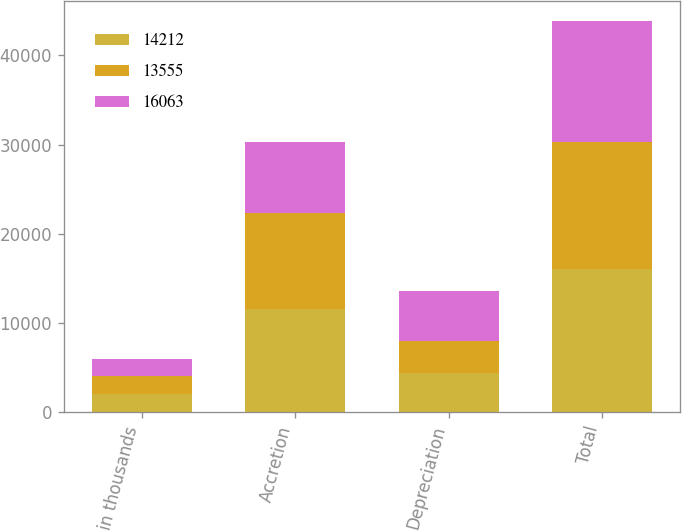<chart> <loc_0><loc_0><loc_500><loc_500><stacked_bar_chart><ecel><fcel>in thousands<fcel>Accretion<fcel>Depreciation<fcel>Total<nl><fcel>14212<fcel>2014<fcel>11601<fcel>4462<fcel>16063<nl><fcel>13555<fcel>2013<fcel>10685<fcel>3527<fcel>14212<nl><fcel>16063<fcel>2012<fcel>7956<fcel>5599<fcel>13555<nl></chart> 